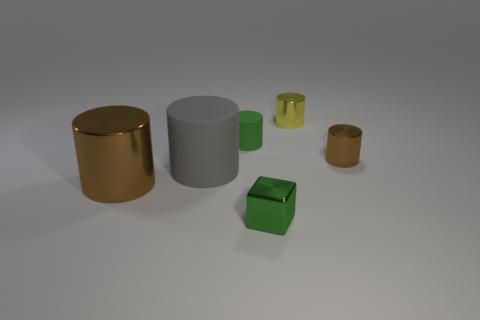Is there anything else that is the same color as the block?
Provide a succinct answer. Yes. What material is the big brown cylinder that is on the left side of the small brown shiny cylinder?
Offer a very short reply. Metal. Do the green rubber cylinder and the green metal object have the same size?
Your answer should be very brief. Yes. What number of other objects are the same size as the green rubber cylinder?
Your response must be concise. 3. Is the tiny matte object the same color as the metallic cube?
Provide a succinct answer. Yes. What shape is the tiny green thing in front of the brown object behind the brown thing left of the metal block?
Offer a very short reply. Cube. What number of things are cylinders that are behind the large gray cylinder or brown things to the right of the yellow thing?
Offer a very short reply. 3. There is a metal object that is in front of the brown cylinder that is left of the tiny green cylinder; what is its size?
Your response must be concise. Small. Do the small shiny object that is right of the small yellow metallic thing and the large metallic cylinder have the same color?
Make the answer very short. Yes. Are there any other large gray rubber objects that have the same shape as the big gray thing?
Offer a very short reply. No. 